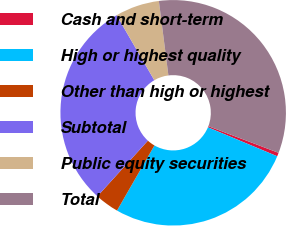<chart> <loc_0><loc_0><loc_500><loc_500><pie_chart><fcel>Cash and short-term<fcel>High or highest quality<fcel>Other than high or highest<fcel>Subtotal<fcel>Public equity securities<fcel>Total<nl><fcel>0.52%<fcel>27.0%<fcel>3.43%<fcel>29.91%<fcel>6.33%<fcel>32.81%<nl></chart> 